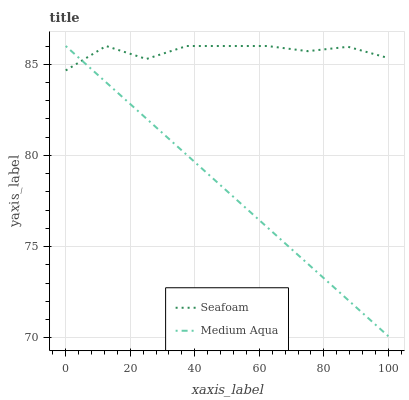Does Medium Aqua have the minimum area under the curve?
Answer yes or no. Yes. Does Seafoam have the maximum area under the curve?
Answer yes or no. Yes. Does Seafoam have the minimum area under the curve?
Answer yes or no. No. Is Medium Aqua the smoothest?
Answer yes or no. Yes. Is Seafoam the roughest?
Answer yes or no. Yes. Is Seafoam the smoothest?
Answer yes or no. No. Does Medium Aqua have the lowest value?
Answer yes or no. Yes. Does Seafoam have the lowest value?
Answer yes or no. No. Does Seafoam have the highest value?
Answer yes or no. Yes. Does Seafoam intersect Medium Aqua?
Answer yes or no. Yes. Is Seafoam less than Medium Aqua?
Answer yes or no. No. Is Seafoam greater than Medium Aqua?
Answer yes or no. No. 